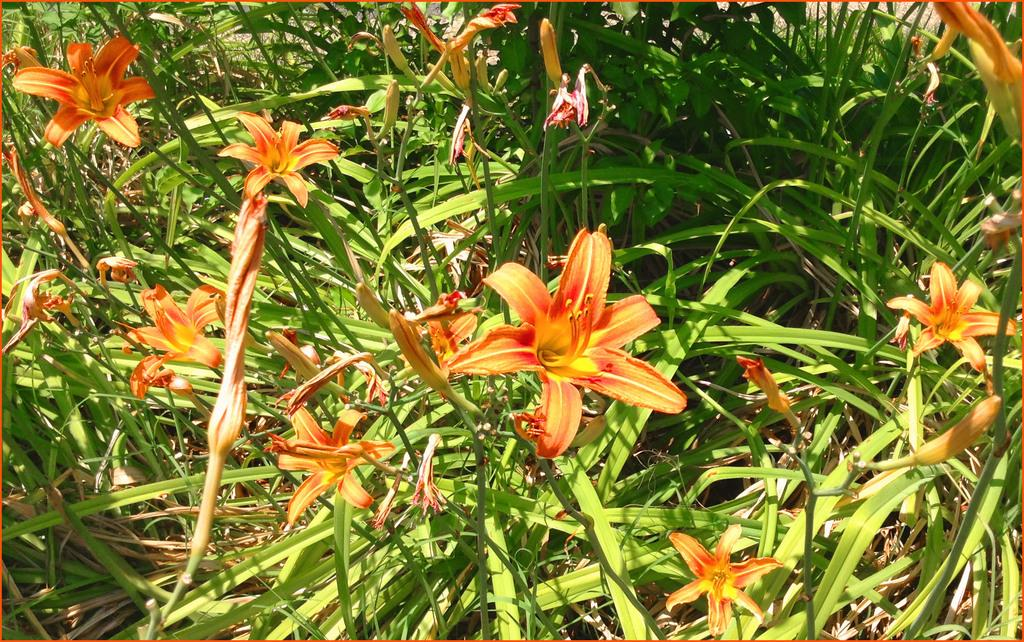What type of living organisms can be seen in the image? Plants can be seen in the image. What specific features can be observed on the plants? The plants have flowers and buds. What type of earthquake can be seen affecting the plants in the image? There is no earthquake present in the image, and the plants are not affected by any such event. How many spiders are visible on the plants in the image? There are no spiders present in the image; it only features plants with flowers and buds. 